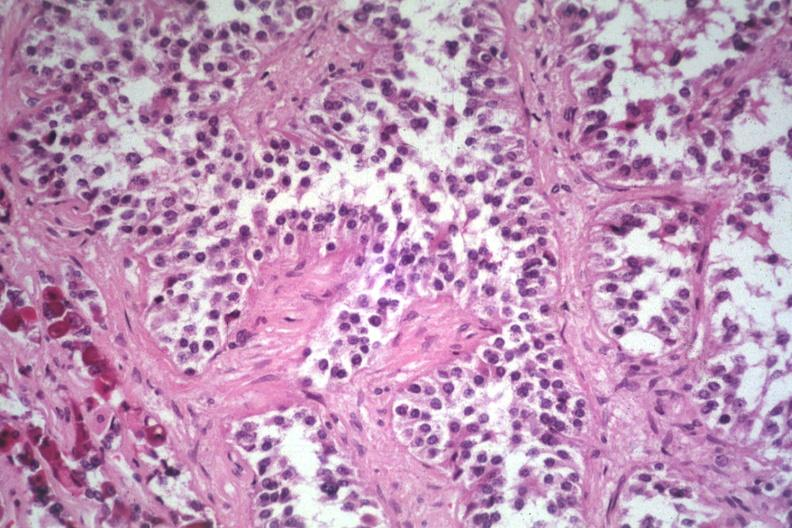where is this part in the figure?
Answer the question using a single word or phrase. Endocrine system 